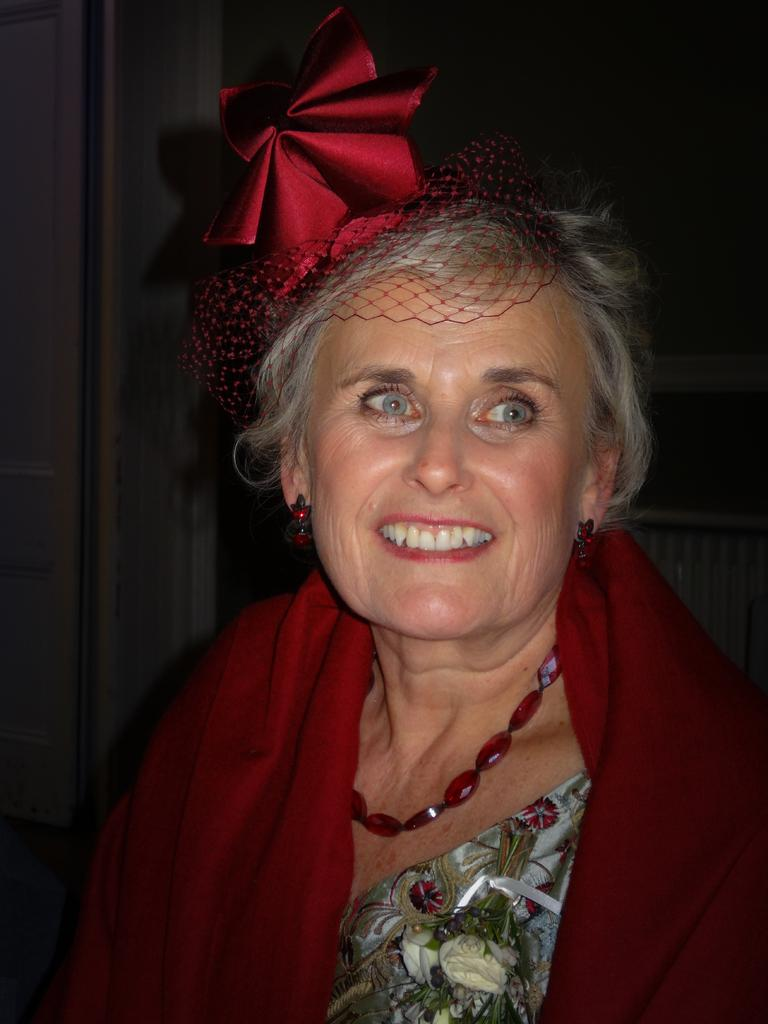Who is present in the image? There is a woman in the image. What is the woman's facial expression? The woman is smiling. What can be observed about the background of the image? The background of the image is dark. What type of wristwatch is the woman wearing in the image? There is no wristwatch visible in the image. What is the source of light in the image? The image does not depict a specific light source; it only shows a woman with a dark background. 